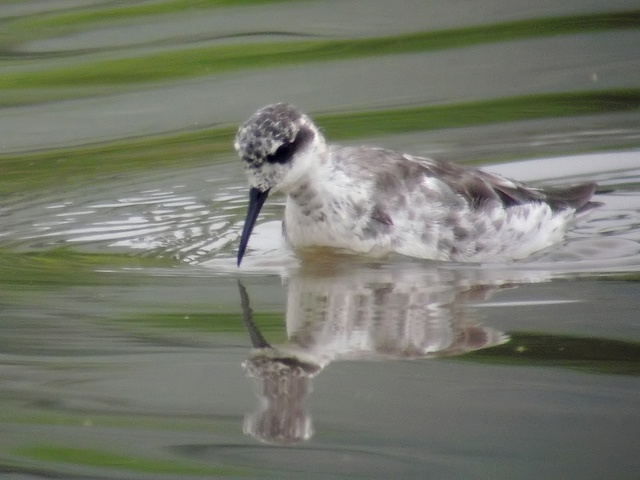Describe the objects in this image and their specific colors. I can see a bird in gray, darkgray, lightgray, and black tones in this image. 